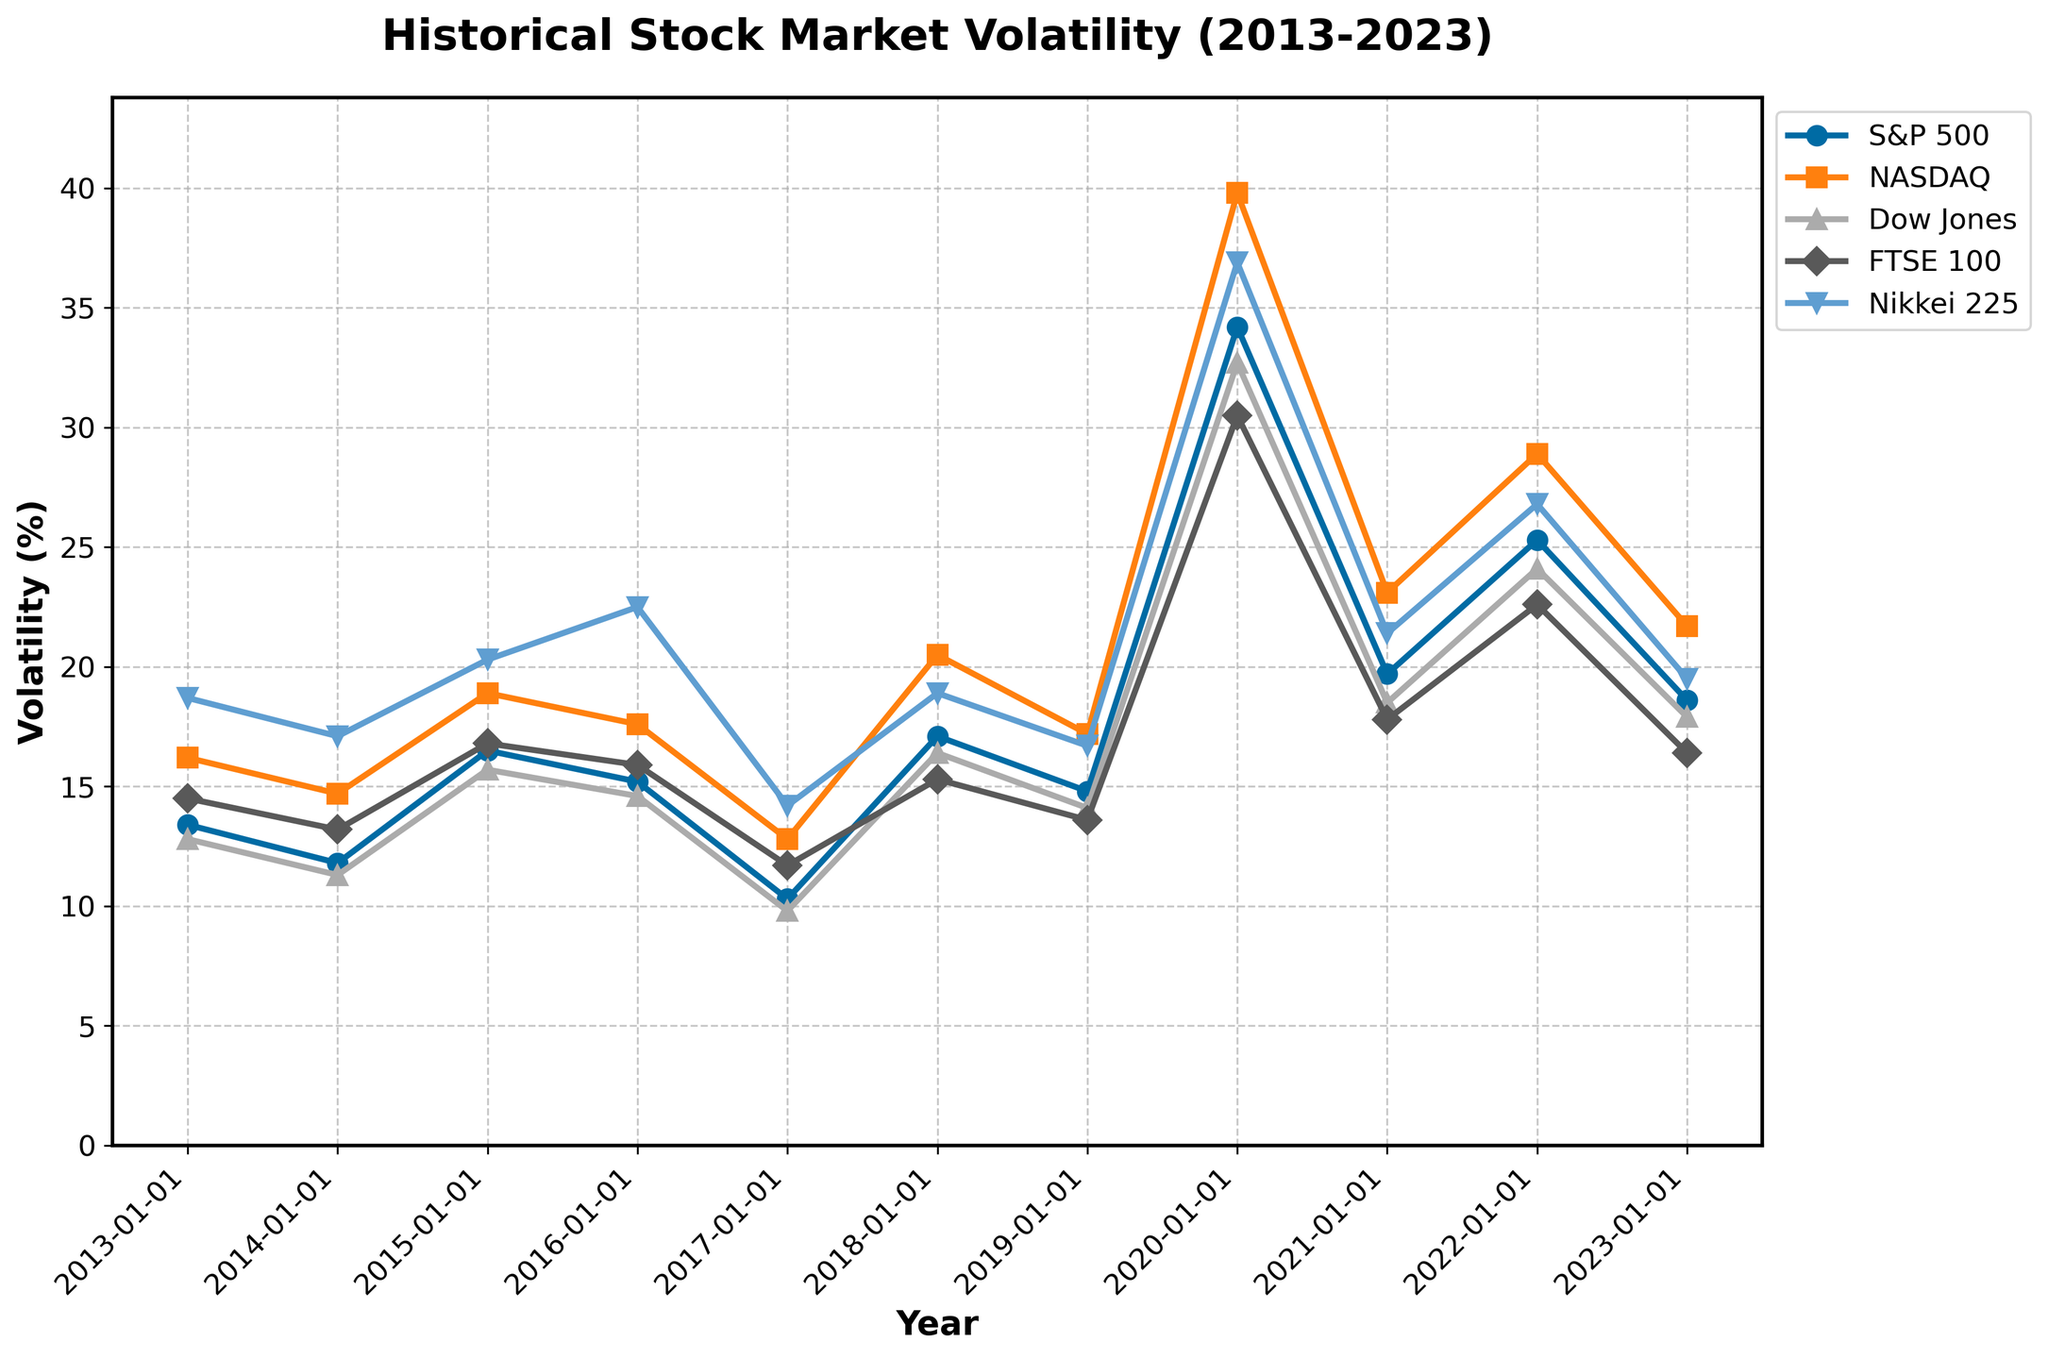What's the volatility trend for the S&P 500 from 2013 to 2023? To determine the trend, visually follow the line plot for the S&P 500 from 2013 to 2023. Note the general direction and changes in volatility levels over time. The S&P 500 volatility started around 13.4% in 2013, decreased slightly until 2017, spiked in 2020 to 34.2%, and then decreased afterwards.
Answer: Decreasing then increasing Which year had the highest volatility for the NASDAQ index? Find the highest point on the NASDAQ line plot and identify the corresponding year on the x-axis. The highest volatility for NASDAQ occurred in 2020.
Answer: 2020 Compare the volatility of the FTSE 100 and Nikkei 225 in 2023. Which one was higher? Locate the values for both FTSE 100 and Nikkei 225 on the y-axis for the year 2023. The FTSE 100 had a volatility of 16.4%, and Nikkei 225 had 19.5%. Hence, Nikkei 225 was higher.
Answer: Nikkei 225 What is the average volatility of the Dow Jones index over the years 2013-2023? Sum all the volatility values for Dow Jones from 2013 to 2023 and divide by the number of years (11). \((12.8+11.3+15.7+14.6+9.8+16.4+14.1+32.7+18.5+24.1+17.9) / 11 = 17.1\).
Answer: 17.1% How did the volatility of major indices behave in the year 2020? Examine the volatility values for each index in 2020. S&P 500 had 34.2%, NASDAQ 39.8%, Dow Jones 32.7%, FTSE 100 30.5%, and Nikkei 225 36.9%. All indices experienced a significant spike in volatility in 2020.
Answer: Spiked significantly Which index had the lowest overall volatility in 2017? Identify the lowest point on each line for the year 2017. The S&P 500 had the lowest volatility with 10.3% in 2017.
Answer: S&P 500 What was the difference in volatility between S&P 500 and NASDAQ in 2018? Find the volatility values for S&P 500 and NASDAQ in 2018 (S&P 500 is 17.1% and NASDAQ is 20.5%). Subtract the S&P 500 value from the NASDAQ value: \(20.5 - 17.1 = 3.4\).
Answer: 3.4% If we average the volatility of all indices in 2019, what value do we get? Sum the 2019 volatilities for all indices and divide by the number of indices (5). \((14.8 + 17.2 + 14.1 + 13.6 + 16.7) / 5 = 15.28\).
Answer: 15.28% Did the Nikkei 225 volatility ever exceed 30% during the period from 2013 to 2023? Look for any point on the Nikkei 225 line plot that exceeds the 30% mark on the y-axis. The highest value was 36.9% in 2020.
Answer: Yes Which indices showed a peak in volatility in the same year? Identify any overlapping peaks across the indices from 2013 to 2023. All indices showed a peak in volatility in 2020.
Answer: All indices 